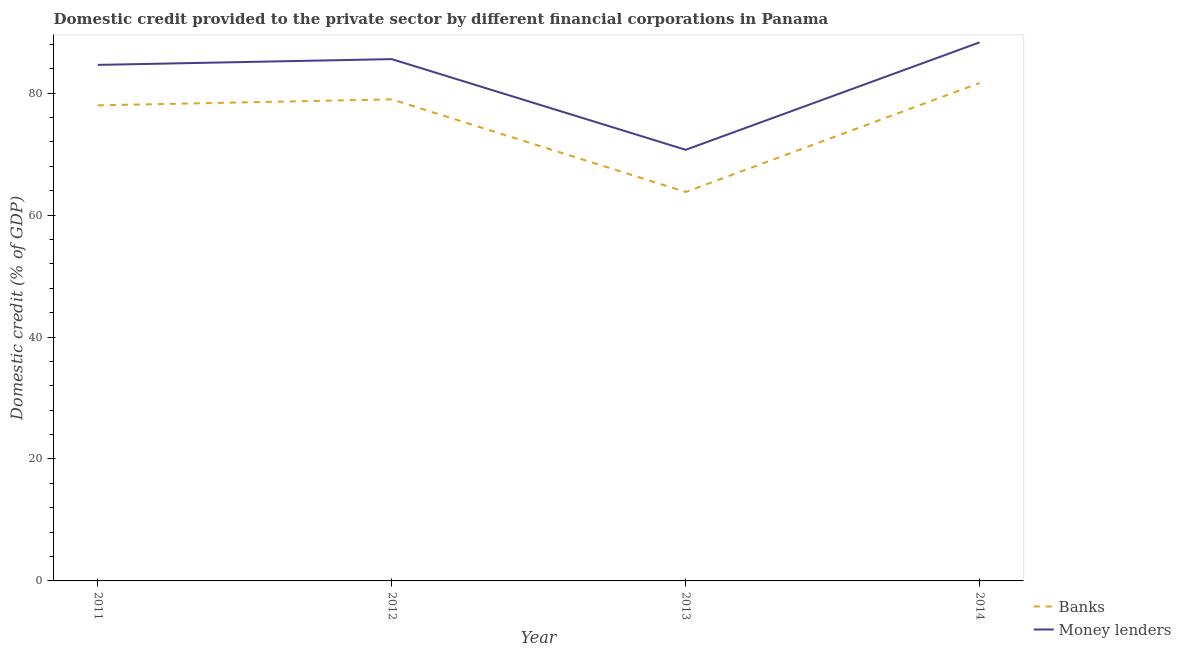Is the number of lines equal to the number of legend labels?
Keep it short and to the point. Yes. What is the domestic credit provided by banks in 2011?
Ensure brevity in your answer.  78.01. Across all years, what is the maximum domestic credit provided by banks?
Ensure brevity in your answer.  81.67. Across all years, what is the minimum domestic credit provided by banks?
Ensure brevity in your answer.  63.8. In which year was the domestic credit provided by banks maximum?
Give a very brief answer. 2014. In which year was the domestic credit provided by money lenders minimum?
Provide a short and direct response. 2013. What is the total domestic credit provided by banks in the graph?
Provide a succinct answer. 302.46. What is the difference between the domestic credit provided by banks in 2012 and that in 2013?
Give a very brief answer. 15.19. What is the difference between the domestic credit provided by banks in 2012 and the domestic credit provided by money lenders in 2013?
Keep it short and to the point. 8.27. What is the average domestic credit provided by money lenders per year?
Your answer should be very brief. 82.32. In the year 2014, what is the difference between the domestic credit provided by money lenders and domestic credit provided by banks?
Offer a very short reply. 6.67. What is the ratio of the domestic credit provided by banks in 2012 to that in 2014?
Offer a very short reply. 0.97. Is the difference between the domestic credit provided by banks in 2011 and 2014 greater than the difference between the domestic credit provided by money lenders in 2011 and 2014?
Your answer should be compact. Yes. What is the difference between the highest and the second highest domestic credit provided by money lenders?
Keep it short and to the point. 2.75. What is the difference between the highest and the lowest domestic credit provided by banks?
Your response must be concise. 17.87. Is the sum of the domestic credit provided by banks in 2012 and 2014 greater than the maximum domestic credit provided by money lenders across all years?
Ensure brevity in your answer.  Yes. Does the domestic credit provided by banks monotonically increase over the years?
Provide a short and direct response. No. Is the domestic credit provided by banks strictly greater than the domestic credit provided by money lenders over the years?
Make the answer very short. No. How many lines are there?
Keep it short and to the point. 2. Does the graph contain any zero values?
Your response must be concise. No. Where does the legend appear in the graph?
Your response must be concise. Bottom right. How many legend labels are there?
Give a very brief answer. 2. How are the legend labels stacked?
Your response must be concise. Vertical. What is the title of the graph?
Your answer should be compact. Domestic credit provided to the private sector by different financial corporations in Panama. What is the label or title of the Y-axis?
Give a very brief answer. Domestic credit (% of GDP). What is the Domestic credit (% of GDP) of Banks in 2011?
Keep it short and to the point. 78.01. What is the Domestic credit (% of GDP) in Money lenders in 2011?
Provide a succinct answer. 84.64. What is the Domestic credit (% of GDP) of Banks in 2012?
Offer a terse response. 78.99. What is the Domestic credit (% of GDP) of Money lenders in 2012?
Ensure brevity in your answer.  85.59. What is the Domestic credit (% of GDP) in Banks in 2013?
Ensure brevity in your answer.  63.8. What is the Domestic credit (% of GDP) in Money lenders in 2013?
Provide a succinct answer. 70.72. What is the Domestic credit (% of GDP) in Banks in 2014?
Your response must be concise. 81.67. What is the Domestic credit (% of GDP) of Money lenders in 2014?
Offer a terse response. 88.34. Across all years, what is the maximum Domestic credit (% of GDP) in Banks?
Keep it short and to the point. 81.67. Across all years, what is the maximum Domestic credit (% of GDP) of Money lenders?
Ensure brevity in your answer.  88.34. Across all years, what is the minimum Domestic credit (% of GDP) in Banks?
Provide a short and direct response. 63.8. Across all years, what is the minimum Domestic credit (% of GDP) in Money lenders?
Make the answer very short. 70.72. What is the total Domestic credit (% of GDP) of Banks in the graph?
Give a very brief answer. 302.46. What is the total Domestic credit (% of GDP) of Money lenders in the graph?
Your answer should be compact. 329.29. What is the difference between the Domestic credit (% of GDP) in Banks in 2011 and that in 2012?
Provide a succinct answer. -0.98. What is the difference between the Domestic credit (% of GDP) of Money lenders in 2011 and that in 2012?
Offer a very short reply. -0.95. What is the difference between the Domestic credit (% of GDP) in Banks in 2011 and that in 2013?
Make the answer very short. 14.21. What is the difference between the Domestic credit (% of GDP) of Money lenders in 2011 and that in 2013?
Your answer should be compact. 13.93. What is the difference between the Domestic credit (% of GDP) in Banks in 2011 and that in 2014?
Make the answer very short. -3.67. What is the difference between the Domestic credit (% of GDP) of Money lenders in 2011 and that in 2014?
Give a very brief answer. -3.7. What is the difference between the Domestic credit (% of GDP) of Banks in 2012 and that in 2013?
Make the answer very short. 15.19. What is the difference between the Domestic credit (% of GDP) in Money lenders in 2012 and that in 2013?
Your answer should be compact. 14.87. What is the difference between the Domestic credit (% of GDP) in Banks in 2012 and that in 2014?
Make the answer very short. -2.69. What is the difference between the Domestic credit (% of GDP) in Money lenders in 2012 and that in 2014?
Provide a short and direct response. -2.75. What is the difference between the Domestic credit (% of GDP) in Banks in 2013 and that in 2014?
Provide a short and direct response. -17.87. What is the difference between the Domestic credit (% of GDP) in Money lenders in 2013 and that in 2014?
Your answer should be very brief. -17.62. What is the difference between the Domestic credit (% of GDP) in Banks in 2011 and the Domestic credit (% of GDP) in Money lenders in 2012?
Offer a very short reply. -7.58. What is the difference between the Domestic credit (% of GDP) of Banks in 2011 and the Domestic credit (% of GDP) of Money lenders in 2013?
Offer a very short reply. 7.29. What is the difference between the Domestic credit (% of GDP) in Banks in 2011 and the Domestic credit (% of GDP) in Money lenders in 2014?
Provide a short and direct response. -10.33. What is the difference between the Domestic credit (% of GDP) of Banks in 2012 and the Domestic credit (% of GDP) of Money lenders in 2013?
Give a very brief answer. 8.27. What is the difference between the Domestic credit (% of GDP) in Banks in 2012 and the Domestic credit (% of GDP) in Money lenders in 2014?
Keep it short and to the point. -9.35. What is the difference between the Domestic credit (% of GDP) of Banks in 2013 and the Domestic credit (% of GDP) of Money lenders in 2014?
Your answer should be very brief. -24.54. What is the average Domestic credit (% of GDP) of Banks per year?
Provide a succinct answer. 75.62. What is the average Domestic credit (% of GDP) in Money lenders per year?
Keep it short and to the point. 82.32. In the year 2011, what is the difference between the Domestic credit (% of GDP) in Banks and Domestic credit (% of GDP) in Money lenders?
Ensure brevity in your answer.  -6.64. In the year 2012, what is the difference between the Domestic credit (% of GDP) in Banks and Domestic credit (% of GDP) in Money lenders?
Offer a terse response. -6.6. In the year 2013, what is the difference between the Domestic credit (% of GDP) in Banks and Domestic credit (% of GDP) in Money lenders?
Your answer should be very brief. -6.92. In the year 2014, what is the difference between the Domestic credit (% of GDP) of Banks and Domestic credit (% of GDP) of Money lenders?
Ensure brevity in your answer.  -6.67. What is the ratio of the Domestic credit (% of GDP) of Banks in 2011 to that in 2012?
Offer a terse response. 0.99. What is the ratio of the Domestic credit (% of GDP) of Money lenders in 2011 to that in 2012?
Make the answer very short. 0.99. What is the ratio of the Domestic credit (% of GDP) of Banks in 2011 to that in 2013?
Ensure brevity in your answer.  1.22. What is the ratio of the Domestic credit (% of GDP) in Money lenders in 2011 to that in 2013?
Provide a succinct answer. 1.2. What is the ratio of the Domestic credit (% of GDP) in Banks in 2011 to that in 2014?
Your answer should be compact. 0.96. What is the ratio of the Domestic credit (% of GDP) in Money lenders in 2011 to that in 2014?
Give a very brief answer. 0.96. What is the ratio of the Domestic credit (% of GDP) in Banks in 2012 to that in 2013?
Keep it short and to the point. 1.24. What is the ratio of the Domestic credit (% of GDP) in Money lenders in 2012 to that in 2013?
Offer a terse response. 1.21. What is the ratio of the Domestic credit (% of GDP) in Banks in 2012 to that in 2014?
Offer a terse response. 0.97. What is the ratio of the Domestic credit (% of GDP) of Money lenders in 2012 to that in 2014?
Make the answer very short. 0.97. What is the ratio of the Domestic credit (% of GDP) of Banks in 2013 to that in 2014?
Keep it short and to the point. 0.78. What is the ratio of the Domestic credit (% of GDP) of Money lenders in 2013 to that in 2014?
Offer a very short reply. 0.8. What is the difference between the highest and the second highest Domestic credit (% of GDP) of Banks?
Offer a very short reply. 2.69. What is the difference between the highest and the second highest Domestic credit (% of GDP) of Money lenders?
Your response must be concise. 2.75. What is the difference between the highest and the lowest Domestic credit (% of GDP) in Banks?
Provide a short and direct response. 17.87. What is the difference between the highest and the lowest Domestic credit (% of GDP) in Money lenders?
Offer a very short reply. 17.62. 